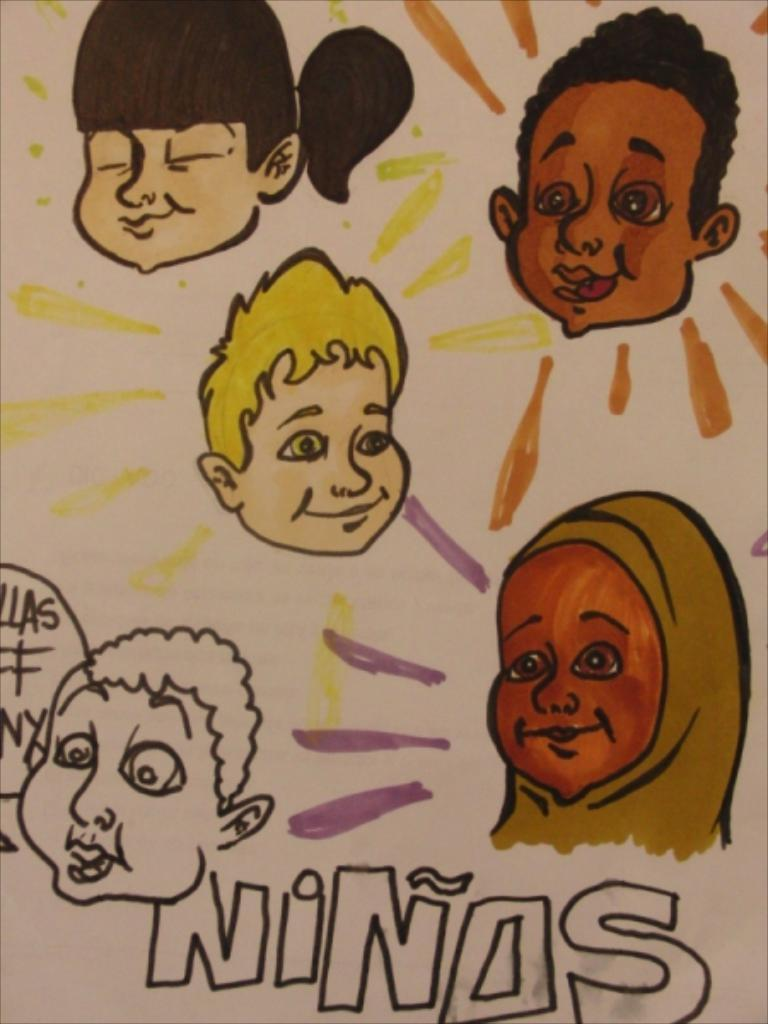What is featured in the image? There is a poster in the image. What type of images are on the poster? The poster has cartoon faces. What else can be found on the poster besides the images? There is text and designs on the poster. What type of ornament is hanging from the top of the poster? There is no ornament hanging from the top of the poster in the image. 